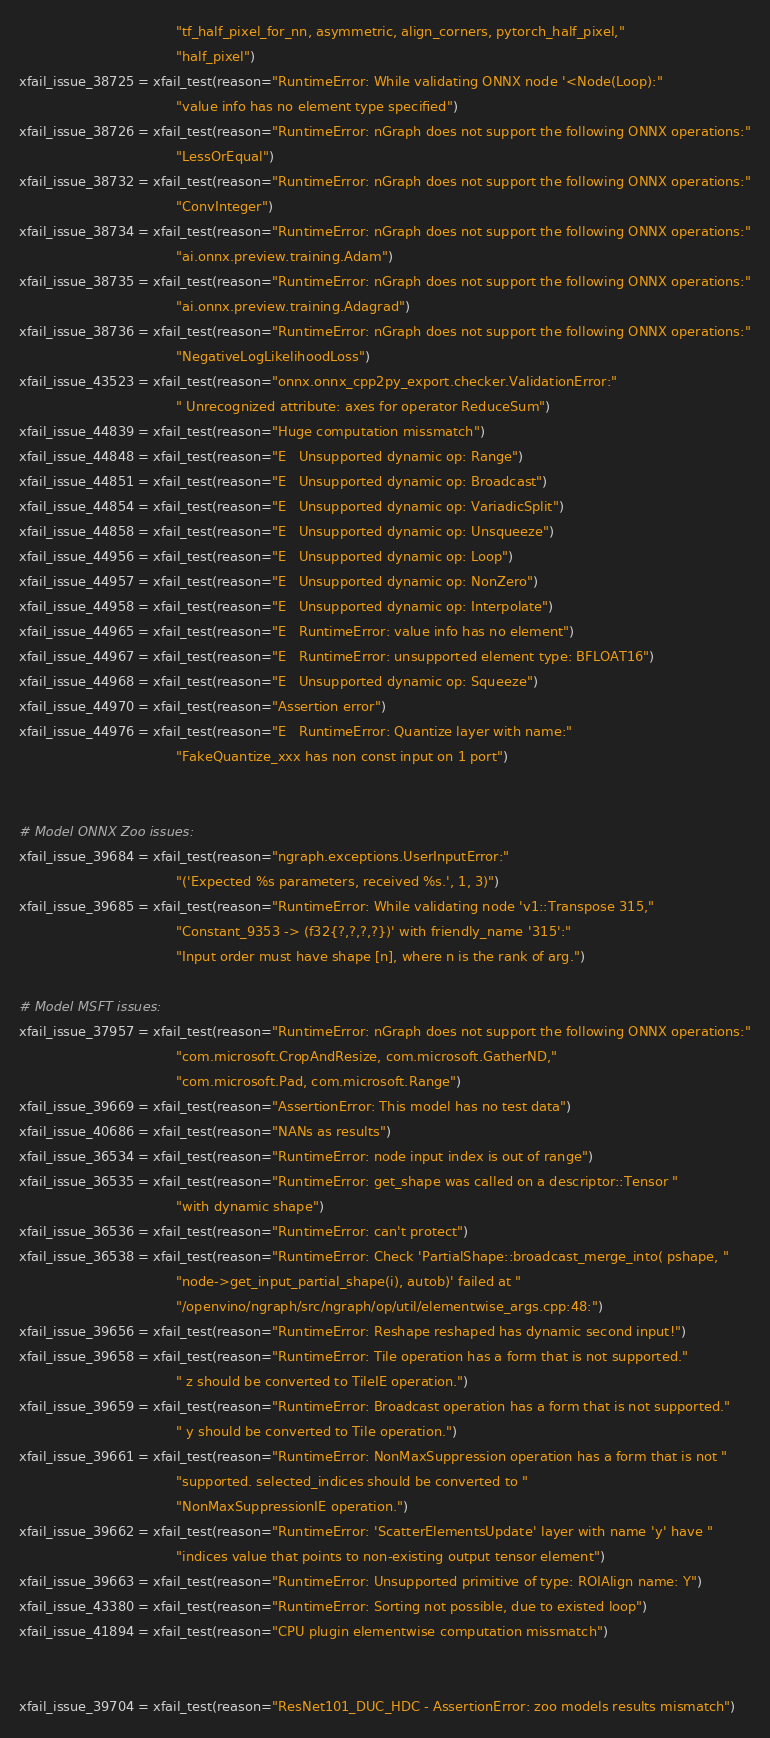<code> <loc_0><loc_0><loc_500><loc_500><_Python_>                                      "tf_half_pixel_for_nn, asymmetric, align_corners, pytorch_half_pixel,"
                                      "half_pixel")
xfail_issue_38725 = xfail_test(reason="RuntimeError: While validating ONNX node '<Node(Loop):"
                                      "value info has no element type specified")
xfail_issue_38726 = xfail_test(reason="RuntimeError: nGraph does not support the following ONNX operations:"
                                      "LessOrEqual")
xfail_issue_38732 = xfail_test(reason="RuntimeError: nGraph does not support the following ONNX operations:"
                                      "ConvInteger")
xfail_issue_38734 = xfail_test(reason="RuntimeError: nGraph does not support the following ONNX operations:"
                                      "ai.onnx.preview.training.Adam")
xfail_issue_38735 = xfail_test(reason="RuntimeError: nGraph does not support the following ONNX operations:"
                                      "ai.onnx.preview.training.Adagrad")
xfail_issue_38736 = xfail_test(reason="RuntimeError: nGraph does not support the following ONNX operations:"
                                      "NegativeLogLikelihoodLoss")
xfail_issue_43523 = xfail_test(reason="onnx.onnx_cpp2py_export.checker.ValidationError:"
                                      " Unrecognized attribute: axes for operator ReduceSum")
xfail_issue_44839 = xfail_test(reason="Huge computation missmatch")
xfail_issue_44848 = xfail_test(reason="E   Unsupported dynamic op: Range")
xfail_issue_44851 = xfail_test(reason="E   Unsupported dynamic op: Broadcast")
xfail_issue_44854 = xfail_test(reason="E   Unsupported dynamic op: VariadicSplit")
xfail_issue_44858 = xfail_test(reason="E   Unsupported dynamic op: Unsqueeze")
xfail_issue_44956 = xfail_test(reason="E   Unsupported dynamic op: Loop")
xfail_issue_44957 = xfail_test(reason="E   Unsupported dynamic op: NonZero")
xfail_issue_44958 = xfail_test(reason="E   Unsupported dynamic op: Interpolate")
xfail_issue_44965 = xfail_test(reason="E   RuntimeError: value info has no element")
xfail_issue_44967 = xfail_test(reason="E   RuntimeError: unsupported element type: BFLOAT16")
xfail_issue_44968 = xfail_test(reason="E   Unsupported dynamic op: Squeeze")
xfail_issue_44970 = xfail_test(reason="Assertion error")
xfail_issue_44976 = xfail_test(reason="E   RuntimeError: Quantize layer with name:"
                                      "FakeQuantize_xxx has non const input on 1 port")


# Model ONNX Zoo issues:
xfail_issue_39684 = xfail_test(reason="ngraph.exceptions.UserInputError:"
                                      "('Expected %s parameters, received %s.', 1, 3)")
xfail_issue_39685 = xfail_test(reason="RuntimeError: While validating node 'v1::Transpose 315,"
                                      "Constant_9353 -> (f32{?,?,?,?})' with friendly_name '315':"
                                      "Input order must have shape [n], where n is the rank of arg.")

# Model MSFT issues:
xfail_issue_37957 = xfail_test(reason="RuntimeError: nGraph does not support the following ONNX operations:"
                                      "com.microsoft.CropAndResize, com.microsoft.GatherND,"
                                      "com.microsoft.Pad, com.microsoft.Range")
xfail_issue_39669 = xfail_test(reason="AssertionError: This model has no test data")
xfail_issue_40686 = xfail_test(reason="NANs as results")
xfail_issue_36534 = xfail_test(reason="RuntimeError: node input index is out of range")
xfail_issue_36535 = xfail_test(reason="RuntimeError: get_shape was called on a descriptor::Tensor "
                                      "with dynamic shape")
xfail_issue_36536 = xfail_test(reason="RuntimeError: can't protect")
xfail_issue_36538 = xfail_test(reason="RuntimeError: Check 'PartialShape::broadcast_merge_into( pshape, "
                                      "node->get_input_partial_shape(i), autob)' failed at "
                                      "/openvino/ngraph/src/ngraph/op/util/elementwise_args.cpp:48:")
xfail_issue_39656 = xfail_test(reason="RuntimeError: Reshape reshaped has dynamic second input!")
xfail_issue_39658 = xfail_test(reason="RuntimeError: Tile operation has a form that is not supported."
                                      " z should be converted to TileIE operation.")
xfail_issue_39659 = xfail_test(reason="RuntimeError: Broadcast operation has a form that is not supported."
                                      " y should be converted to Tile operation.")
xfail_issue_39661 = xfail_test(reason="RuntimeError: NonMaxSuppression operation has a form that is not "
                                      "supported. selected_indices should be converted to "
                                      "NonMaxSuppressionIE operation.")
xfail_issue_39662 = xfail_test(reason="RuntimeError: 'ScatterElementsUpdate' layer with name 'y' have "
                                      "indices value that points to non-existing output tensor element")
xfail_issue_39663 = xfail_test(reason="RuntimeError: Unsupported primitive of type: ROIAlign name: Y")
xfail_issue_43380 = xfail_test(reason="RuntimeError: Sorting not possible, due to existed loop")
xfail_issue_41894 = xfail_test(reason="CPU plugin elementwise computation missmatch")


xfail_issue_39704 = xfail_test(reason="ResNet101_DUC_HDC - AssertionError: zoo models results mismatch")</code> 